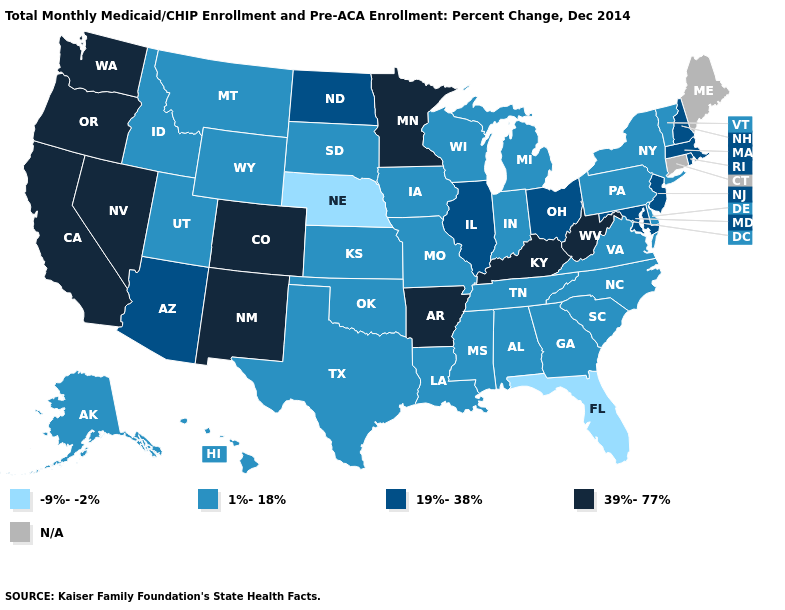What is the highest value in the USA?
Quick response, please. 39%-77%. Is the legend a continuous bar?
Be succinct. No. What is the value of Pennsylvania?
Give a very brief answer. 1%-18%. What is the lowest value in the USA?
Answer briefly. -9%--2%. What is the lowest value in the USA?
Keep it brief. -9%--2%. Which states hav the highest value in the South?
Answer briefly. Arkansas, Kentucky, West Virginia. Is the legend a continuous bar?
Write a very short answer. No. Name the states that have a value in the range 1%-18%?
Quick response, please. Alabama, Alaska, Delaware, Georgia, Hawaii, Idaho, Indiana, Iowa, Kansas, Louisiana, Michigan, Mississippi, Missouri, Montana, New York, North Carolina, Oklahoma, Pennsylvania, South Carolina, South Dakota, Tennessee, Texas, Utah, Vermont, Virginia, Wisconsin, Wyoming. How many symbols are there in the legend?
Write a very short answer. 5. What is the value of Indiana?
Quick response, please. 1%-18%. Name the states that have a value in the range 39%-77%?
Quick response, please. Arkansas, California, Colorado, Kentucky, Minnesota, Nevada, New Mexico, Oregon, Washington, West Virginia. Among the states that border Michigan , which have the highest value?
Short answer required. Ohio. Name the states that have a value in the range -9%--2%?
Concise answer only. Florida, Nebraska. Name the states that have a value in the range 19%-38%?
Short answer required. Arizona, Illinois, Maryland, Massachusetts, New Hampshire, New Jersey, North Dakota, Ohio, Rhode Island. 